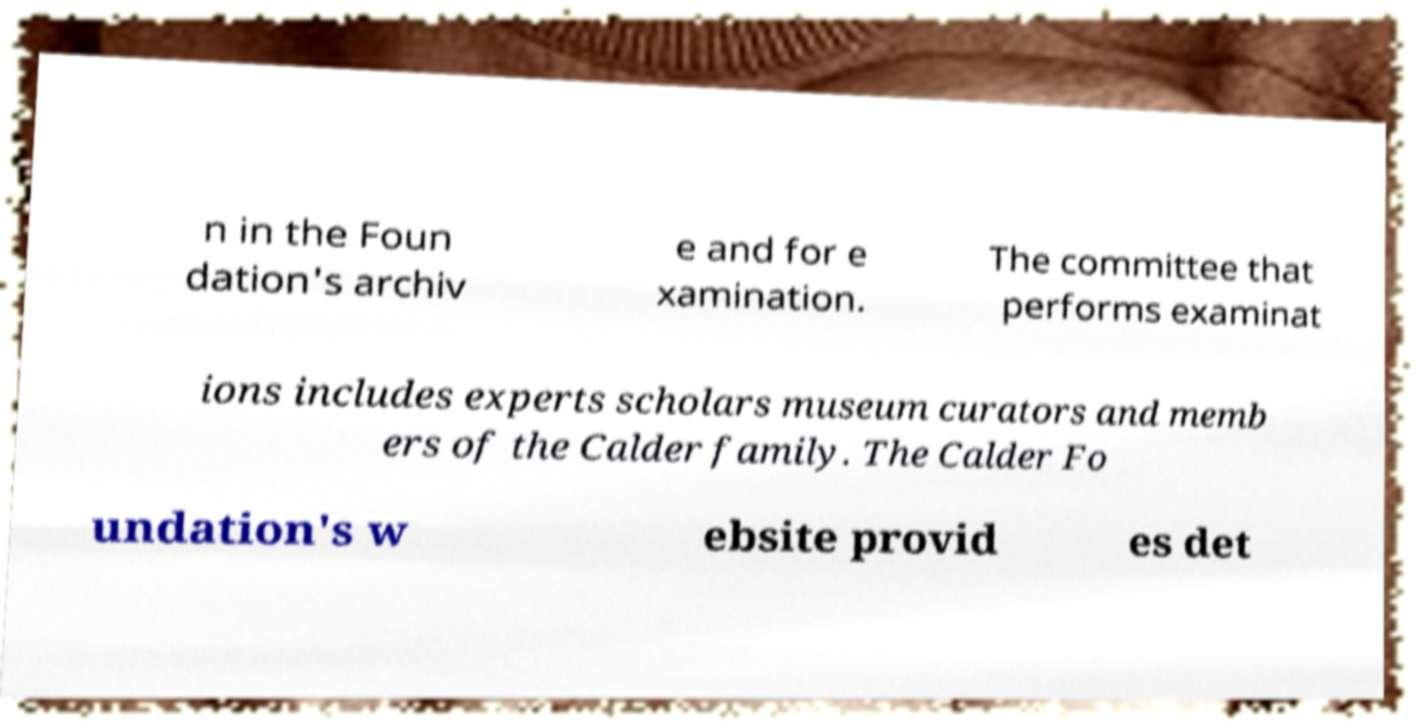Please read and relay the text visible in this image. What does it say? n in the Foun dation's archiv e and for e xamination. The committee that performs examinat ions includes experts scholars museum curators and memb ers of the Calder family. The Calder Fo undation's w ebsite provid es det 